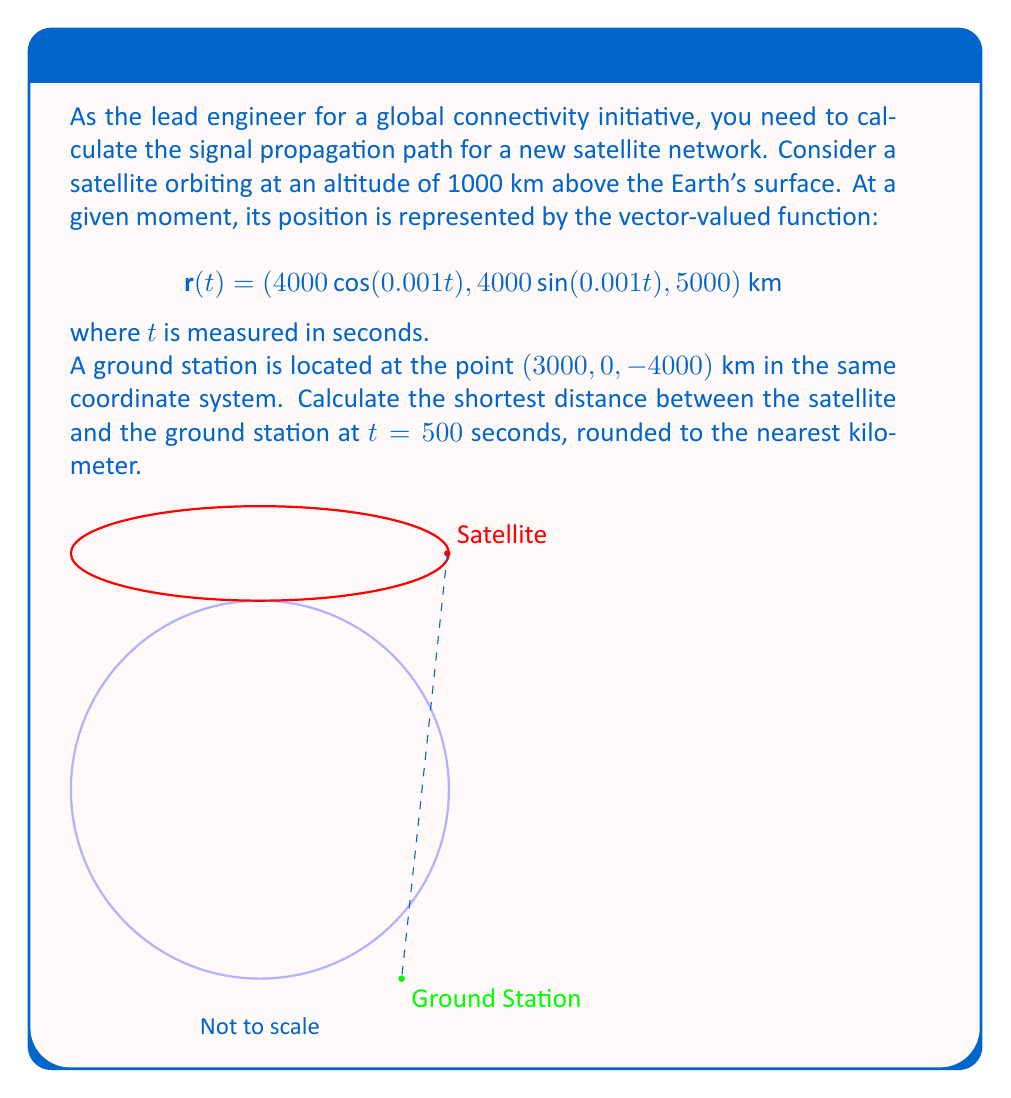Can you solve this math problem? Let's approach this step-by-step:

1) First, we need to find the position of the satellite at $t = 500$ seconds:

   $$\mathbf{r}(500) = (4000\cos(0.5), 4000\sin(0.5), 5000) \text{ km}$$

2) The ground station's position is given as $(3000, 0, -4000)$ km.

3) To find the distance between these two points, we can use the distance formula in 3D space:

   $$d = \sqrt{(x_2-x_1)^2 + (y_2-y_1)^2 + (z_2-z_1)^2}$$

4) Let's calculate each component:
   
   $x_2 - x_1 = 3000 - 4000\cos(0.5)$
   $y_2 - y_1 = 0 - 4000\sin(0.5)$
   $z_2 - z_1 = -4000 - 5000 = -9000$

5) Substituting into the distance formula:

   $$d = \sqrt{(3000 - 4000\cos(0.5))^2 + (-4000\sin(0.5))^2 + (-9000)^2}$$

6) Evaluating this expression:

   $$d = \sqrt{(3000 - 4000 * 0.8776)^2 + (-4000 * 0.4794)^2 + (-9000)^2}$$
   $$d = \sqrt{(-492.44)^2 + (-1917.6)^2 + (-9000)^2}$$
   $$d = \sqrt{242,497 + 3,677,190 + 81,000,000}$$
   $$d = \sqrt{84,919,687} \approx 9215.7 \text{ km}$$

7) Rounding to the nearest kilometer:

   $$d \approx 9216 \text{ km}$$
Answer: 9216 km 